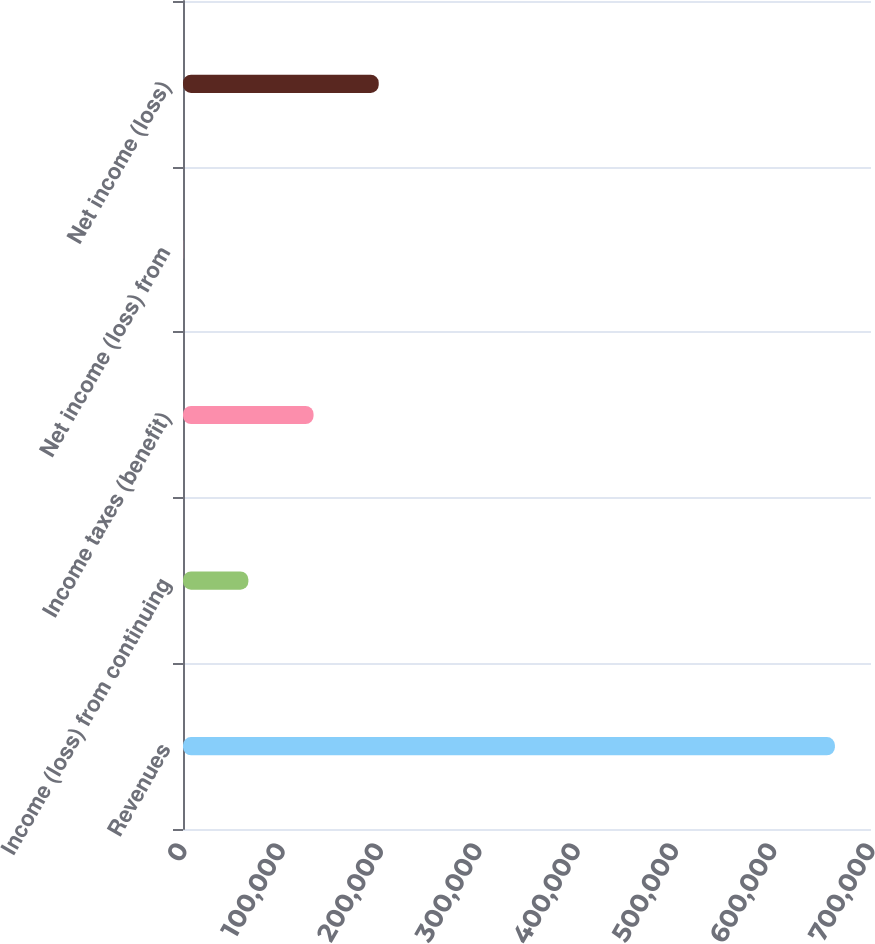<chart> <loc_0><loc_0><loc_500><loc_500><bar_chart><fcel>Revenues<fcel>Income (loss) from continuing<fcel>Income taxes (benefit)<fcel>Net income (loss) from<fcel>Net income (loss)<nl><fcel>663280<fcel>66524.2<fcel>132830<fcel>218<fcel>199137<nl></chart> 